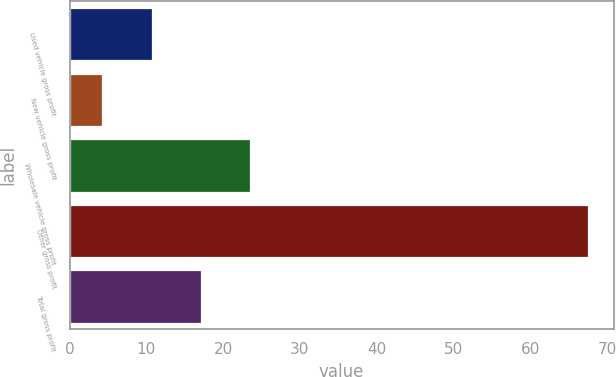Convert chart to OTSL. <chart><loc_0><loc_0><loc_500><loc_500><bar_chart><fcel>Used vehicle gross profit<fcel>New vehicle gross profit<fcel>Wholesale vehicle gross profit<fcel>Other gross profit<fcel>Total gross profit<nl><fcel>10.8<fcel>4.2<fcel>23.46<fcel>67.5<fcel>17.13<nl></chart> 